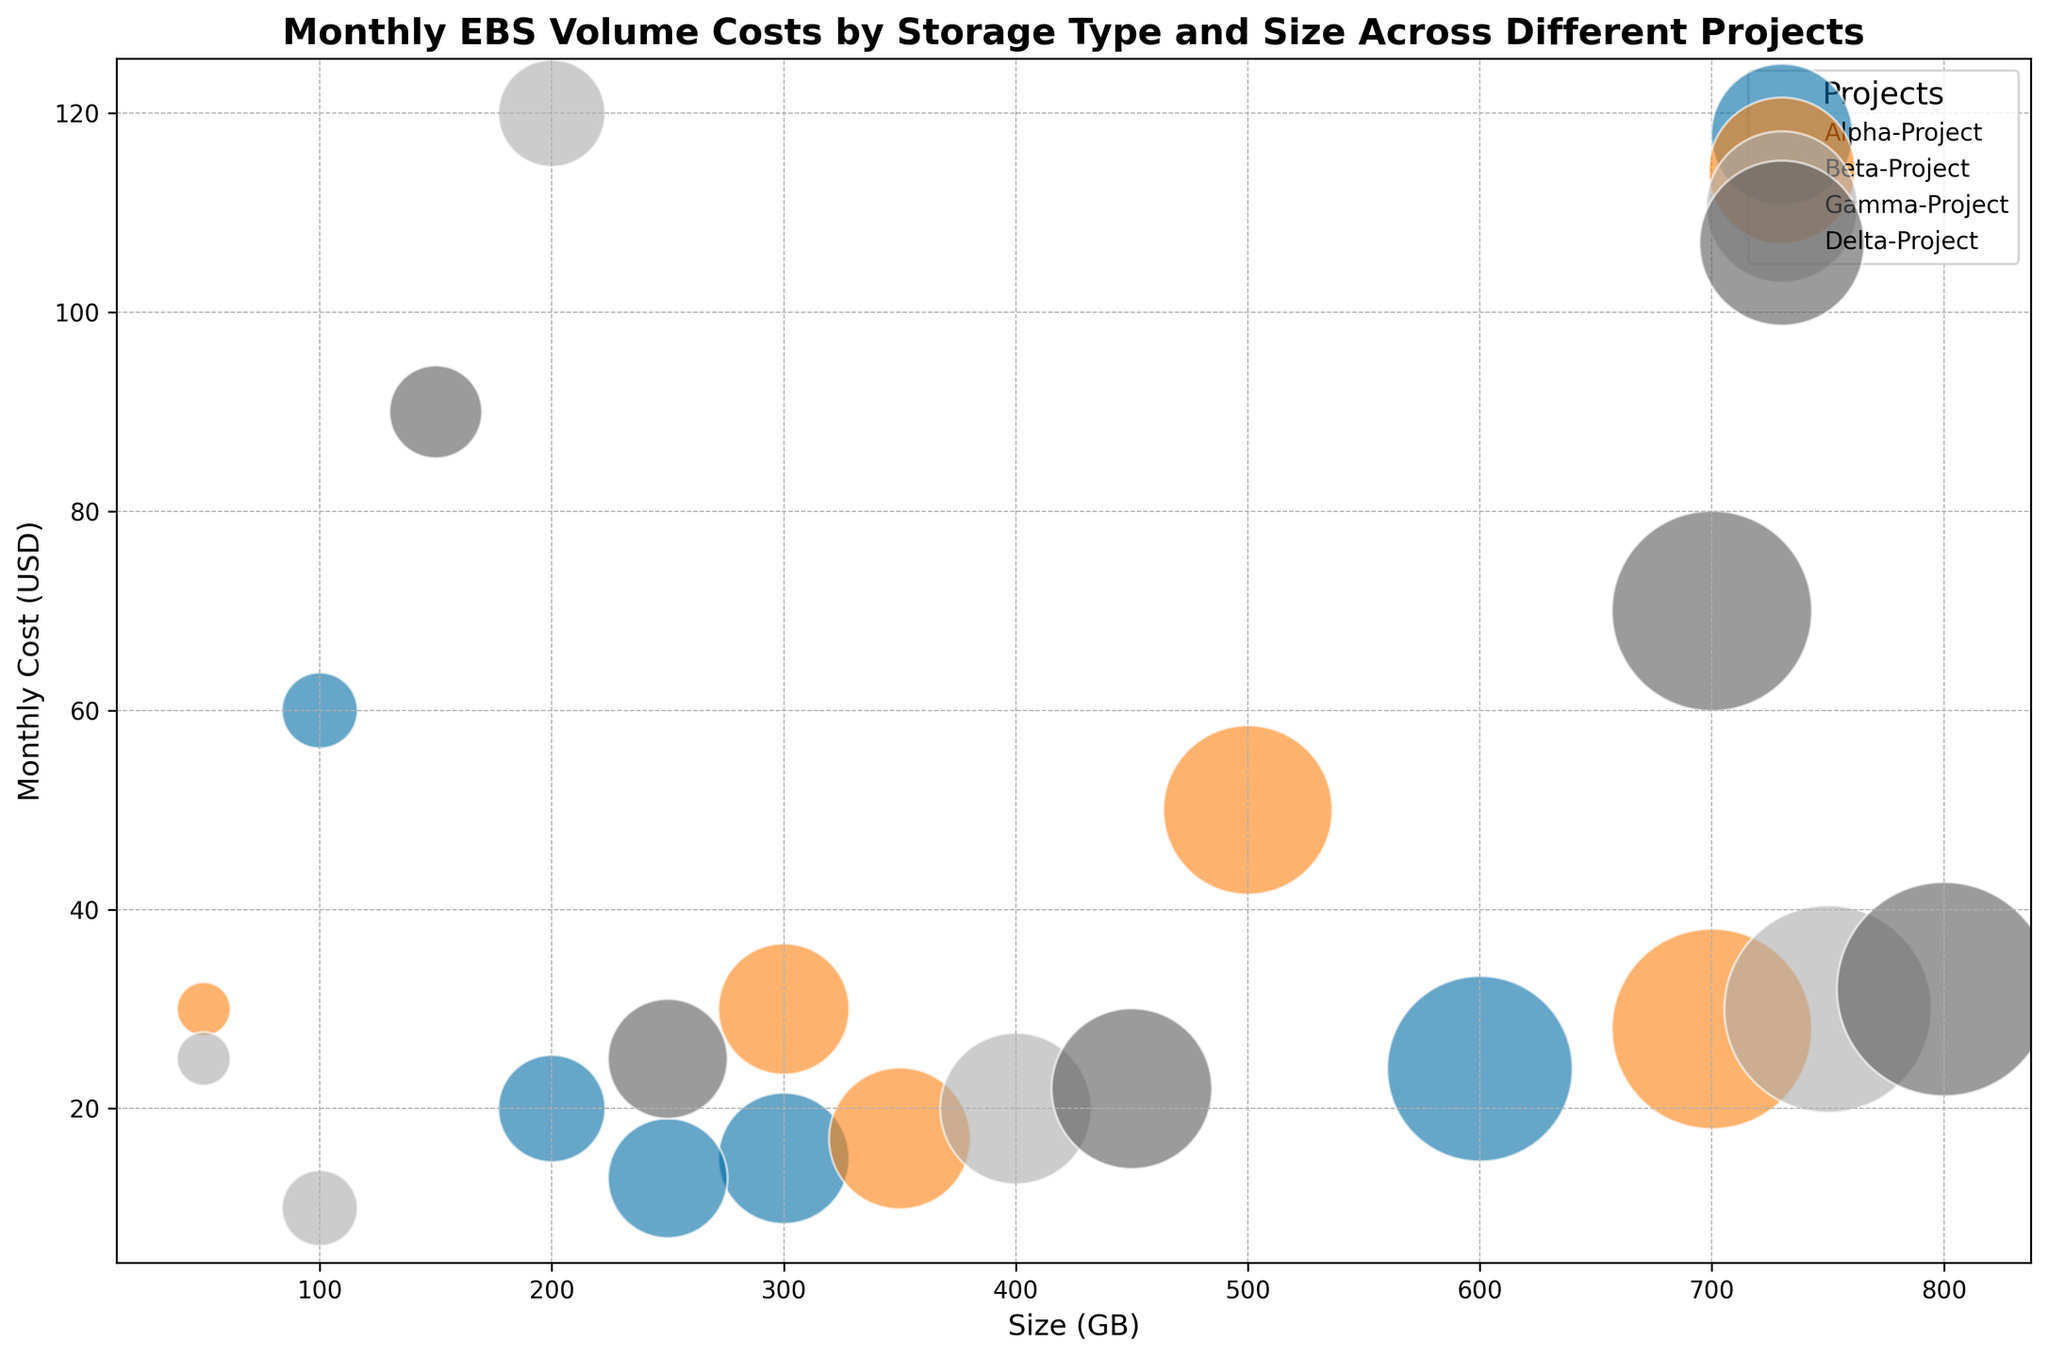Which project has the highest monthly EBS volume cost? Look at the size of each bubble; the largest bubble represents the highest cost. For the highest monthly cost, look for the bubble with the highest y-value on the USD axis.
Answer: Gamma-Project What is the combined monthly EBS volume cost for all General Purpose (gp2) volumes in the Delta-Project? Identify the General Purpose (gp2) volumes in the Delta-Project and sum up their monthly costs: 250GB costs 25 USD and 700GB costs 70 USD. Adding them gives 25 + 70 = 95 USD.
Answer: 95 USD Which storage type has the largest size in the Beta-Project? Identify the storage types in the Beta-Project and find the one with the highest size value on the x-axis. The storage type with the largest size is the Cold HDD (sc1) with 700GB.
Answer: Cold HDD (sc1) What is the difference in monthly EBS volume cost between the largest and smallest volumes in the Alpha-Project? Identify the largest and smallest volumes in the Alpha-Project by size (600GB and 100GB, respectively). Calculate their costs (24 USD and 60 USD, respectively). The difference is
Answer: 36 USD Which project has the most cost-efficient storage (lowest cost per GB)? Calculate the cost per GB for each storage type (MonthlyCostUSD/SizeGB). The project with the smallest ratio has the most cost-efficient storage. The Alpha-Project has the Throughput Optimized (st1) storage type with a ratio of 15/300 = 0.05 USD/GB.
Answer: Alpha-Project Is there any project that exclusively uses the Cold HDD (sc1) storage type? Check which projects have Cold HDD (sc1) volumes and determine if any project uses this storage type exclusively. All projects (Alpha, Beta, Gamma, Delta) have other storage types in use.
Answer: No Which storage type has the highest monthly cost in the Gamma-Project? Identify storage types in the Gamma-Project and check their monthly costs. The Provisioned IOPS (io1) storage type has the highest cost, 120 USD.
Answer: Provisioned IOPS (io1) How much more does the largest General Purpose (gp2) volume in Gamma-Project cost compared to the smallest? Identify volumes, largest is 100GB (10 USD), smallest is 50GB (25 USD). The difference is 10 - 25 = -15 USD (largest is cheaper than smallest).
Answer: -15 USD What are the color and size of the bubbles for the Throughput Optimized (st1) volumes? Throughput Optimized (st1) volumes: Alpha-Project (300GB, 15 USD), Beta-Project (350GB, 17 USD), Gamma-Project (400GB, 20 USD), Delta-Project (450GB, 22 USD). All bubbles are in various sizes corresponding to these values and specific colors for each project (e.g., possibly represented by the same color per project by different sizes).
Answer: (various sizes, project specific colors) Do any projects have multiple storage types with identical sizes? Compare the sizes within each project. No projects display identical sizes across multiple storage types within the same project.
Answer: No 